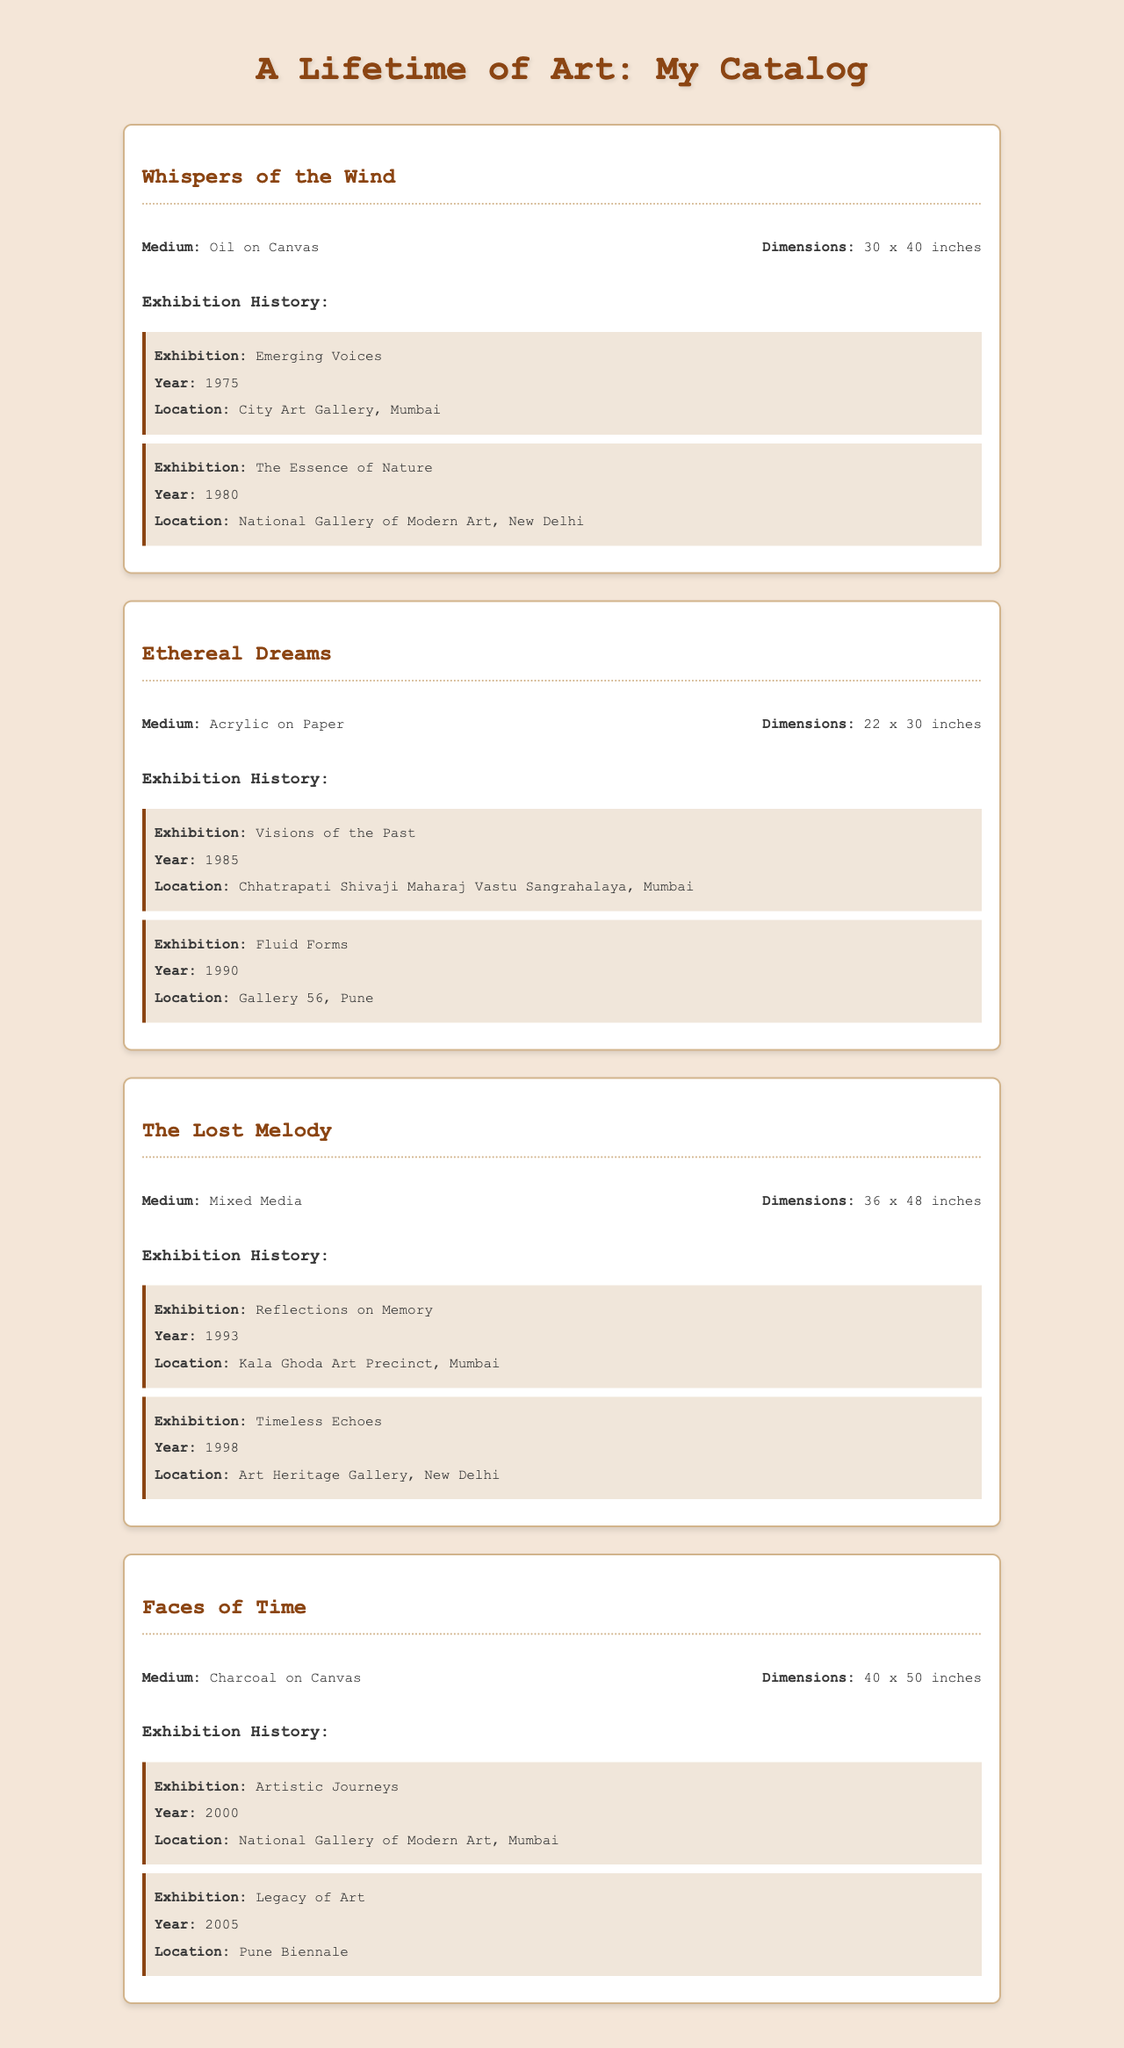What is the title of the first artwork? The title of the first artwork is found in the heading of the first artwork section.
Answer: Whispers of the Wind What medium is used in "Ethereal Dreams"? The medium information is located in the artwork details section under the artwork title.
Answer: Acrylic on Paper What were the dimensions of "The Lost Melody"? The dimensions are specified in the artwork details section for that piece.
Answer: 36 x 48 inches In which year was "Faces of Time" exhibited at the National Gallery of Modern Art? The year of the exhibition is mentioned in the exhibition history section for that artwork.
Answer: 2000 How many exhibitions did "Whispers of the Wind" participate in? The number of exhibitions is determined by counting the exhibition entries listed under that artwork.
Answer: 2 Which location hosted the "Timeless Echoes" exhibition? The location is given in the exhibition history for "The Lost Melody".
Answer: Art Heritage Gallery, New Delhi What type of artwork is "Faces of Time"? The type of artwork can be identified by the medium mentioned in the artwork details.
Answer: Charcoal on Canvas What is the common theme of the exhibitions listed? A theme can be derived by analyzing the titles of the exhibitions and their focus areas.
Answer: Art and Nature 